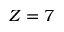Convert formula to latex. <formula><loc_0><loc_0><loc_500><loc_500>Z = 7</formula> 